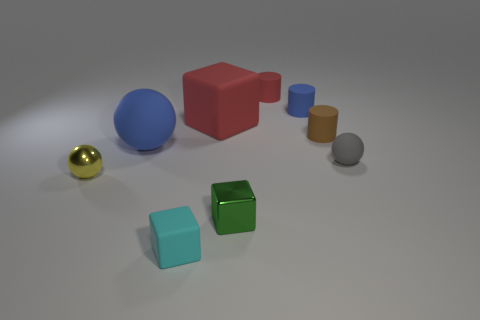What is the size of the red matte thing that is the same shape as the tiny brown rubber object?
Your response must be concise. Small. There is a big object that is the same shape as the small gray rubber thing; what is its color?
Ensure brevity in your answer.  Blue. Do the metal ball and the tiny matte ball to the right of the small cyan matte thing have the same color?
Your response must be concise. No. There is a small ball that is on the right side of the small metallic thing that is on the right side of the tiny yellow metallic sphere; what is its color?
Make the answer very short. Gray. The cube that is the same size as the green metallic thing is what color?
Ensure brevity in your answer.  Cyan. Is there a big green metal object of the same shape as the small green object?
Ensure brevity in your answer.  No. What is the shape of the green thing?
Ensure brevity in your answer.  Cube. Are there more green metal objects behind the small blue rubber cylinder than tiny green metal cubes that are behind the big red thing?
Your response must be concise. No. How many other things are the same size as the red rubber cylinder?
Your answer should be very brief. 6. What material is the tiny object that is behind the green thing and left of the small green block?
Provide a succinct answer. Metal. 